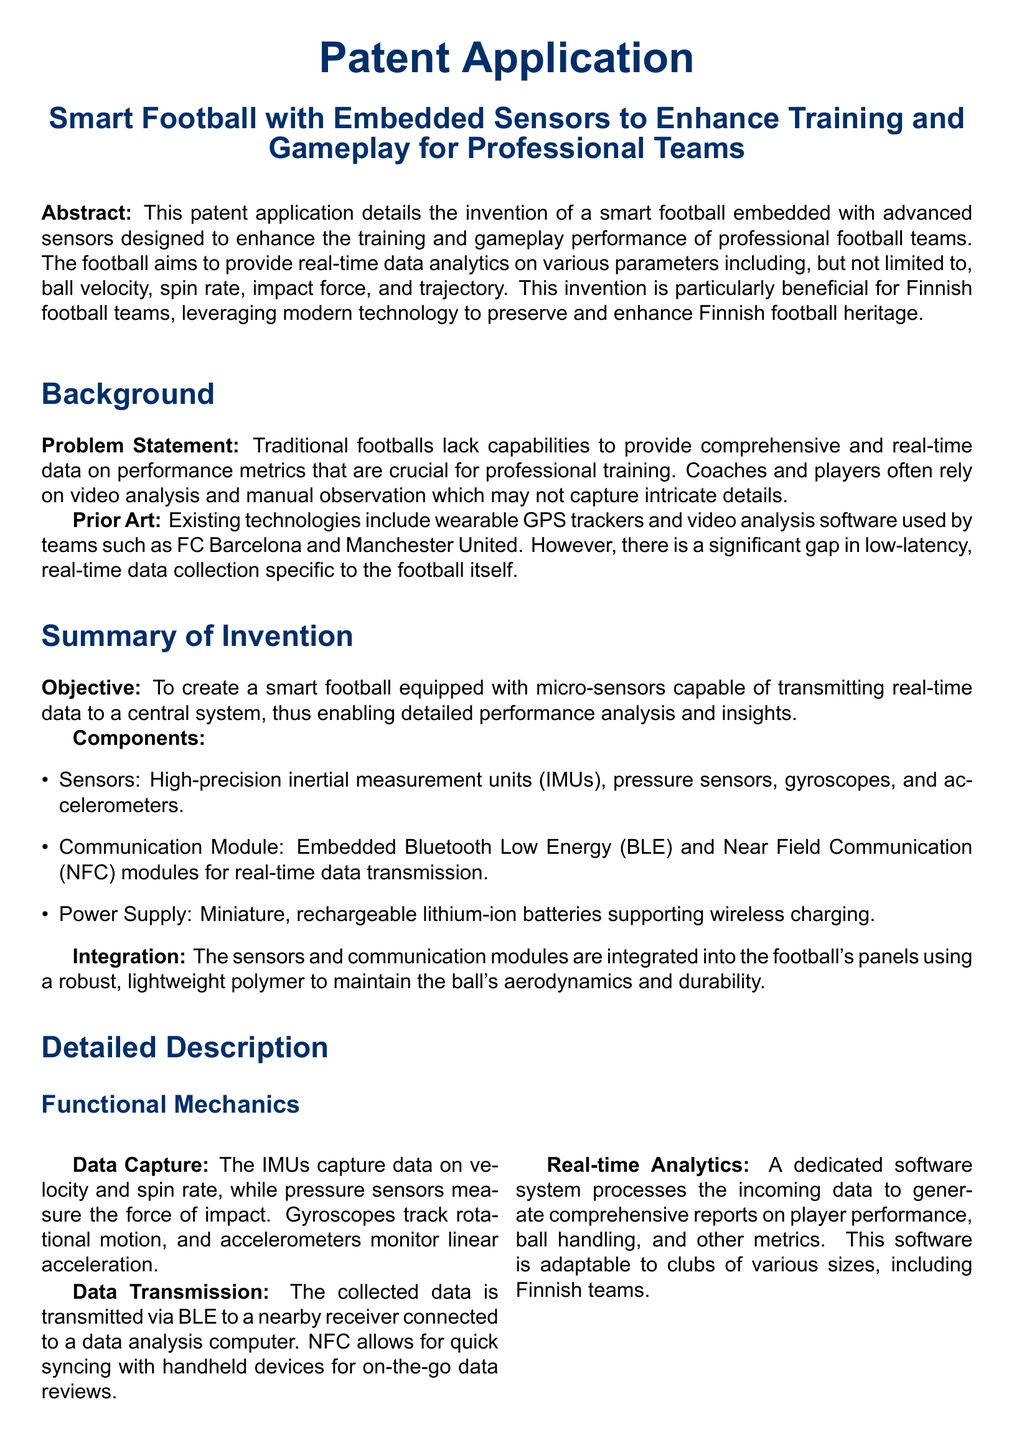What is the main objective of the invention? The main objective is to create a smart football equipped with micro-sensors capable of transmitting real-time data to a central system.
Answer: To create a smart football equipped with micro-sensors What types of sensors are integrated into the smart football? The document lists high-precision inertial measurement units, pressure sensors, gyroscopes, and accelerometers as the components.
Answer: IMUs, pressure sensors, gyroscopes, accelerometers Which Finnish football club is mentioned as an example for training use? HJK Helsinki is specifically mentioned as a club that can utilize the smart football for training.
Answer: HJK Helsinki What communication technologies are used in the smart football? The document mentions Bluetooth Low Energy and Near Field Communication as the communication modules.
Answer: Bluetooth Low Energy and Near Field Communication How does the smart football enhance training? It facilitates a data-driven approach to improve individual player skills and overall team strategies.
Answer: Data-driven approach to improve skills and strategies What is the significance of real-time data transmission? Real-time data transmission allows for immediate insights and instant modifications during games.
Answer: Immediate insights and instant modifications during games 